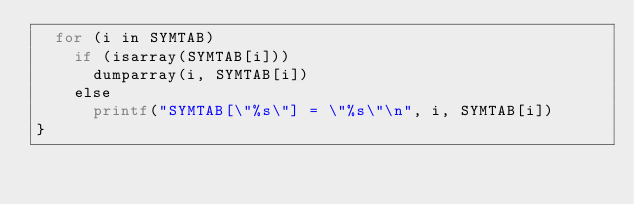<code> <loc_0><loc_0><loc_500><loc_500><_Awk_>	for (i in SYMTAB)
		if (isarray(SYMTAB[i]))
			dumparray(i, SYMTAB[i])
		else
			printf("SYMTAB[\"%s\"] = \"%s\"\n", i, SYMTAB[i])
}
</code> 